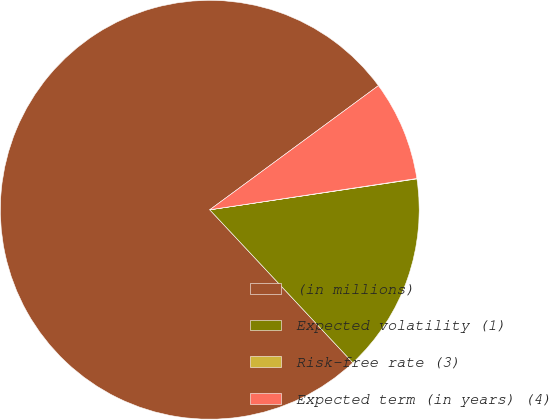<chart> <loc_0><loc_0><loc_500><loc_500><pie_chart><fcel>(in millions)<fcel>Expected volatility (1)<fcel>Risk-free rate (3)<fcel>Expected term (in years) (4)<nl><fcel>76.87%<fcel>15.39%<fcel>0.03%<fcel>7.71%<nl></chart> 